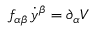Convert formula to latex. <formula><loc_0><loc_0><loc_500><loc_500>f _ { \alpha \beta } \, \dot { y } ^ { \beta } = \partial _ { \alpha } V</formula> 